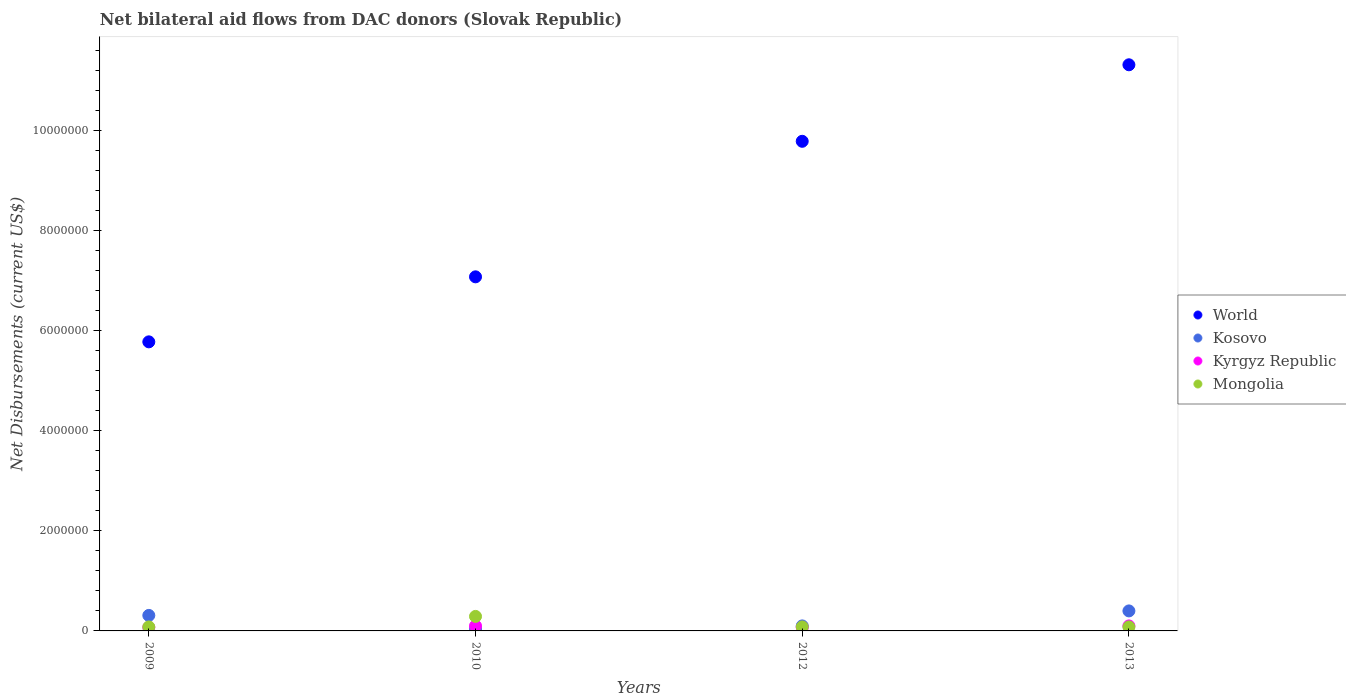How many different coloured dotlines are there?
Provide a succinct answer. 4. What is the net bilateral aid flows in World in 2012?
Your answer should be compact. 9.79e+06. Across all years, what is the maximum net bilateral aid flows in World?
Ensure brevity in your answer.  1.13e+07. Across all years, what is the minimum net bilateral aid flows in Kosovo?
Ensure brevity in your answer.  4.00e+04. In which year was the net bilateral aid flows in Mongolia maximum?
Your answer should be compact. 2010. What is the total net bilateral aid flows in Mongolia in the graph?
Offer a very short reply. 5.30e+05. What is the average net bilateral aid flows in Kyrgyz Republic per year?
Provide a short and direct response. 8.50e+04. In the year 2009, what is the difference between the net bilateral aid flows in Kosovo and net bilateral aid flows in Kyrgyz Republic?
Offer a very short reply. 2.40e+05. What is the ratio of the net bilateral aid flows in Mongolia in 2010 to that in 2012?
Offer a very short reply. 3.62. Is the net bilateral aid flows in World in 2009 less than that in 2010?
Your response must be concise. Yes. Is the difference between the net bilateral aid flows in Kosovo in 2009 and 2010 greater than the difference between the net bilateral aid flows in Kyrgyz Republic in 2009 and 2010?
Give a very brief answer. Yes. What is the difference between the highest and the lowest net bilateral aid flows in World?
Your answer should be very brief. 5.54e+06. In how many years, is the net bilateral aid flows in Kosovo greater than the average net bilateral aid flows in Kosovo taken over all years?
Offer a terse response. 2. Is it the case that in every year, the sum of the net bilateral aid flows in Mongolia and net bilateral aid flows in Kosovo  is greater than the net bilateral aid flows in Kyrgyz Republic?
Offer a very short reply. Yes. Is the net bilateral aid flows in World strictly greater than the net bilateral aid flows in Kyrgyz Republic over the years?
Ensure brevity in your answer.  Yes. Is the net bilateral aid flows in Mongolia strictly less than the net bilateral aid flows in Kyrgyz Republic over the years?
Give a very brief answer. No. How many years are there in the graph?
Give a very brief answer. 4. What is the difference between two consecutive major ticks on the Y-axis?
Your answer should be compact. 2.00e+06. Are the values on the major ticks of Y-axis written in scientific E-notation?
Your answer should be very brief. No. Does the graph contain any zero values?
Provide a short and direct response. No. Does the graph contain grids?
Your response must be concise. No. Where does the legend appear in the graph?
Give a very brief answer. Center right. How many legend labels are there?
Provide a short and direct response. 4. What is the title of the graph?
Keep it short and to the point. Net bilateral aid flows from DAC donors (Slovak Republic). Does "Norway" appear as one of the legend labels in the graph?
Your response must be concise. No. What is the label or title of the X-axis?
Give a very brief answer. Years. What is the label or title of the Y-axis?
Provide a succinct answer. Net Disbursements (current US$). What is the Net Disbursements (current US$) of World in 2009?
Provide a short and direct response. 5.78e+06. What is the Net Disbursements (current US$) of Kosovo in 2009?
Give a very brief answer. 3.10e+05. What is the Net Disbursements (current US$) of World in 2010?
Your response must be concise. 7.08e+06. What is the Net Disbursements (current US$) in World in 2012?
Offer a very short reply. 9.79e+06. What is the Net Disbursements (current US$) of Kyrgyz Republic in 2012?
Your answer should be very brief. 7.00e+04. What is the Net Disbursements (current US$) of World in 2013?
Your answer should be very brief. 1.13e+07. What is the Net Disbursements (current US$) of Kosovo in 2013?
Give a very brief answer. 4.00e+05. Across all years, what is the maximum Net Disbursements (current US$) in World?
Offer a very short reply. 1.13e+07. Across all years, what is the maximum Net Disbursements (current US$) in Mongolia?
Your answer should be very brief. 2.90e+05. Across all years, what is the minimum Net Disbursements (current US$) in World?
Provide a succinct answer. 5.78e+06. Across all years, what is the minimum Net Disbursements (current US$) of Kyrgyz Republic?
Your answer should be very brief. 7.00e+04. What is the total Net Disbursements (current US$) in World in the graph?
Your answer should be compact. 3.40e+07. What is the total Net Disbursements (current US$) of Kosovo in the graph?
Your answer should be very brief. 8.50e+05. What is the total Net Disbursements (current US$) in Kyrgyz Republic in the graph?
Ensure brevity in your answer.  3.40e+05. What is the total Net Disbursements (current US$) in Mongolia in the graph?
Provide a short and direct response. 5.30e+05. What is the difference between the Net Disbursements (current US$) in World in 2009 and that in 2010?
Give a very brief answer. -1.30e+06. What is the difference between the Net Disbursements (current US$) in Kosovo in 2009 and that in 2010?
Your response must be concise. 2.70e+05. What is the difference between the Net Disbursements (current US$) of Kyrgyz Republic in 2009 and that in 2010?
Provide a short and direct response. -3.00e+04. What is the difference between the Net Disbursements (current US$) of Mongolia in 2009 and that in 2010?
Offer a very short reply. -2.10e+05. What is the difference between the Net Disbursements (current US$) of World in 2009 and that in 2012?
Offer a terse response. -4.01e+06. What is the difference between the Net Disbursements (current US$) of Kosovo in 2009 and that in 2012?
Offer a very short reply. 2.10e+05. What is the difference between the Net Disbursements (current US$) of Kyrgyz Republic in 2009 and that in 2012?
Your response must be concise. 0. What is the difference between the Net Disbursements (current US$) of Mongolia in 2009 and that in 2012?
Ensure brevity in your answer.  0. What is the difference between the Net Disbursements (current US$) of World in 2009 and that in 2013?
Provide a succinct answer. -5.54e+06. What is the difference between the Net Disbursements (current US$) of Kyrgyz Republic in 2009 and that in 2013?
Offer a terse response. -3.00e+04. What is the difference between the Net Disbursements (current US$) of Mongolia in 2009 and that in 2013?
Offer a very short reply. 0. What is the difference between the Net Disbursements (current US$) in World in 2010 and that in 2012?
Offer a terse response. -2.71e+06. What is the difference between the Net Disbursements (current US$) in World in 2010 and that in 2013?
Offer a very short reply. -4.24e+06. What is the difference between the Net Disbursements (current US$) of Kosovo in 2010 and that in 2013?
Your answer should be compact. -3.60e+05. What is the difference between the Net Disbursements (current US$) of Kyrgyz Republic in 2010 and that in 2013?
Offer a terse response. 0. What is the difference between the Net Disbursements (current US$) of Mongolia in 2010 and that in 2013?
Make the answer very short. 2.10e+05. What is the difference between the Net Disbursements (current US$) of World in 2012 and that in 2013?
Offer a very short reply. -1.53e+06. What is the difference between the Net Disbursements (current US$) in Mongolia in 2012 and that in 2013?
Make the answer very short. 0. What is the difference between the Net Disbursements (current US$) of World in 2009 and the Net Disbursements (current US$) of Kosovo in 2010?
Give a very brief answer. 5.74e+06. What is the difference between the Net Disbursements (current US$) of World in 2009 and the Net Disbursements (current US$) of Kyrgyz Republic in 2010?
Offer a terse response. 5.68e+06. What is the difference between the Net Disbursements (current US$) of World in 2009 and the Net Disbursements (current US$) of Mongolia in 2010?
Make the answer very short. 5.49e+06. What is the difference between the Net Disbursements (current US$) in Kosovo in 2009 and the Net Disbursements (current US$) in Kyrgyz Republic in 2010?
Offer a terse response. 2.10e+05. What is the difference between the Net Disbursements (current US$) of Kyrgyz Republic in 2009 and the Net Disbursements (current US$) of Mongolia in 2010?
Offer a very short reply. -2.20e+05. What is the difference between the Net Disbursements (current US$) of World in 2009 and the Net Disbursements (current US$) of Kosovo in 2012?
Your response must be concise. 5.68e+06. What is the difference between the Net Disbursements (current US$) in World in 2009 and the Net Disbursements (current US$) in Kyrgyz Republic in 2012?
Offer a terse response. 5.71e+06. What is the difference between the Net Disbursements (current US$) of World in 2009 and the Net Disbursements (current US$) of Mongolia in 2012?
Your answer should be very brief. 5.70e+06. What is the difference between the Net Disbursements (current US$) in Kosovo in 2009 and the Net Disbursements (current US$) in Kyrgyz Republic in 2012?
Your answer should be compact. 2.40e+05. What is the difference between the Net Disbursements (current US$) of World in 2009 and the Net Disbursements (current US$) of Kosovo in 2013?
Provide a short and direct response. 5.38e+06. What is the difference between the Net Disbursements (current US$) of World in 2009 and the Net Disbursements (current US$) of Kyrgyz Republic in 2013?
Offer a very short reply. 5.68e+06. What is the difference between the Net Disbursements (current US$) in World in 2009 and the Net Disbursements (current US$) in Mongolia in 2013?
Offer a terse response. 5.70e+06. What is the difference between the Net Disbursements (current US$) in Kosovo in 2009 and the Net Disbursements (current US$) in Mongolia in 2013?
Provide a short and direct response. 2.30e+05. What is the difference between the Net Disbursements (current US$) of World in 2010 and the Net Disbursements (current US$) of Kosovo in 2012?
Your response must be concise. 6.98e+06. What is the difference between the Net Disbursements (current US$) of World in 2010 and the Net Disbursements (current US$) of Kyrgyz Republic in 2012?
Your answer should be very brief. 7.01e+06. What is the difference between the Net Disbursements (current US$) of World in 2010 and the Net Disbursements (current US$) of Mongolia in 2012?
Offer a very short reply. 7.00e+06. What is the difference between the Net Disbursements (current US$) of World in 2010 and the Net Disbursements (current US$) of Kosovo in 2013?
Make the answer very short. 6.68e+06. What is the difference between the Net Disbursements (current US$) in World in 2010 and the Net Disbursements (current US$) in Kyrgyz Republic in 2013?
Your answer should be very brief. 6.98e+06. What is the difference between the Net Disbursements (current US$) in Kyrgyz Republic in 2010 and the Net Disbursements (current US$) in Mongolia in 2013?
Your answer should be compact. 2.00e+04. What is the difference between the Net Disbursements (current US$) of World in 2012 and the Net Disbursements (current US$) of Kosovo in 2013?
Provide a short and direct response. 9.39e+06. What is the difference between the Net Disbursements (current US$) of World in 2012 and the Net Disbursements (current US$) of Kyrgyz Republic in 2013?
Your answer should be compact. 9.69e+06. What is the difference between the Net Disbursements (current US$) in World in 2012 and the Net Disbursements (current US$) in Mongolia in 2013?
Make the answer very short. 9.71e+06. What is the difference between the Net Disbursements (current US$) in Kosovo in 2012 and the Net Disbursements (current US$) in Mongolia in 2013?
Give a very brief answer. 2.00e+04. What is the difference between the Net Disbursements (current US$) in Kyrgyz Republic in 2012 and the Net Disbursements (current US$) in Mongolia in 2013?
Provide a succinct answer. -10000. What is the average Net Disbursements (current US$) in World per year?
Offer a very short reply. 8.49e+06. What is the average Net Disbursements (current US$) in Kosovo per year?
Keep it short and to the point. 2.12e+05. What is the average Net Disbursements (current US$) in Kyrgyz Republic per year?
Ensure brevity in your answer.  8.50e+04. What is the average Net Disbursements (current US$) of Mongolia per year?
Offer a very short reply. 1.32e+05. In the year 2009, what is the difference between the Net Disbursements (current US$) in World and Net Disbursements (current US$) in Kosovo?
Offer a very short reply. 5.47e+06. In the year 2009, what is the difference between the Net Disbursements (current US$) in World and Net Disbursements (current US$) in Kyrgyz Republic?
Provide a short and direct response. 5.71e+06. In the year 2009, what is the difference between the Net Disbursements (current US$) of World and Net Disbursements (current US$) of Mongolia?
Provide a succinct answer. 5.70e+06. In the year 2009, what is the difference between the Net Disbursements (current US$) in Kosovo and Net Disbursements (current US$) in Kyrgyz Republic?
Keep it short and to the point. 2.40e+05. In the year 2009, what is the difference between the Net Disbursements (current US$) of Kyrgyz Republic and Net Disbursements (current US$) of Mongolia?
Your answer should be compact. -10000. In the year 2010, what is the difference between the Net Disbursements (current US$) in World and Net Disbursements (current US$) in Kosovo?
Keep it short and to the point. 7.04e+06. In the year 2010, what is the difference between the Net Disbursements (current US$) of World and Net Disbursements (current US$) of Kyrgyz Republic?
Your answer should be very brief. 6.98e+06. In the year 2010, what is the difference between the Net Disbursements (current US$) in World and Net Disbursements (current US$) in Mongolia?
Offer a very short reply. 6.79e+06. In the year 2010, what is the difference between the Net Disbursements (current US$) of Kosovo and Net Disbursements (current US$) of Kyrgyz Republic?
Offer a very short reply. -6.00e+04. In the year 2010, what is the difference between the Net Disbursements (current US$) of Kosovo and Net Disbursements (current US$) of Mongolia?
Your response must be concise. -2.50e+05. In the year 2010, what is the difference between the Net Disbursements (current US$) in Kyrgyz Republic and Net Disbursements (current US$) in Mongolia?
Give a very brief answer. -1.90e+05. In the year 2012, what is the difference between the Net Disbursements (current US$) in World and Net Disbursements (current US$) in Kosovo?
Offer a very short reply. 9.69e+06. In the year 2012, what is the difference between the Net Disbursements (current US$) of World and Net Disbursements (current US$) of Kyrgyz Republic?
Your answer should be compact. 9.72e+06. In the year 2012, what is the difference between the Net Disbursements (current US$) of World and Net Disbursements (current US$) of Mongolia?
Your answer should be compact. 9.71e+06. In the year 2012, what is the difference between the Net Disbursements (current US$) in Kosovo and Net Disbursements (current US$) in Kyrgyz Republic?
Provide a succinct answer. 3.00e+04. In the year 2013, what is the difference between the Net Disbursements (current US$) in World and Net Disbursements (current US$) in Kosovo?
Give a very brief answer. 1.09e+07. In the year 2013, what is the difference between the Net Disbursements (current US$) in World and Net Disbursements (current US$) in Kyrgyz Republic?
Offer a very short reply. 1.12e+07. In the year 2013, what is the difference between the Net Disbursements (current US$) in World and Net Disbursements (current US$) in Mongolia?
Provide a short and direct response. 1.12e+07. In the year 2013, what is the difference between the Net Disbursements (current US$) of Kosovo and Net Disbursements (current US$) of Kyrgyz Republic?
Keep it short and to the point. 3.00e+05. In the year 2013, what is the difference between the Net Disbursements (current US$) of Kyrgyz Republic and Net Disbursements (current US$) of Mongolia?
Make the answer very short. 2.00e+04. What is the ratio of the Net Disbursements (current US$) in World in 2009 to that in 2010?
Ensure brevity in your answer.  0.82. What is the ratio of the Net Disbursements (current US$) of Kosovo in 2009 to that in 2010?
Your answer should be very brief. 7.75. What is the ratio of the Net Disbursements (current US$) in Mongolia in 2009 to that in 2010?
Ensure brevity in your answer.  0.28. What is the ratio of the Net Disbursements (current US$) of World in 2009 to that in 2012?
Give a very brief answer. 0.59. What is the ratio of the Net Disbursements (current US$) in Kosovo in 2009 to that in 2012?
Your response must be concise. 3.1. What is the ratio of the Net Disbursements (current US$) in Mongolia in 2009 to that in 2012?
Your answer should be very brief. 1. What is the ratio of the Net Disbursements (current US$) of World in 2009 to that in 2013?
Provide a succinct answer. 0.51. What is the ratio of the Net Disbursements (current US$) in Kosovo in 2009 to that in 2013?
Your answer should be very brief. 0.78. What is the ratio of the Net Disbursements (current US$) of Kyrgyz Republic in 2009 to that in 2013?
Keep it short and to the point. 0.7. What is the ratio of the Net Disbursements (current US$) of Mongolia in 2009 to that in 2013?
Offer a terse response. 1. What is the ratio of the Net Disbursements (current US$) in World in 2010 to that in 2012?
Your response must be concise. 0.72. What is the ratio of the Net Disbursements (current US$) of Kyrgyz Republic in 2010 to that in 2012?
Make the answer very short. 1.43. What is the ratio of the Net Disbursements (current US$) in Mongolia in 2010 to that in 2012?
Offer a terse response. 3.62. What is the ratio of the Net Disbursements (current US$) of World in 2010 to that in 2013?
Make the answer very short. 0.63. What is the ratio of the Net Disbursements (current US$) of Kosovo in 2010 to that in 2013?
Keep it short and to the point. 0.1. What is the ratio of the Net Disbursements (current US$) of Mongolia in 2010 to that in 2013?
Keep it short and to the point. 3.62. What is the ratio of the Net Disbursements (current US$) of World in 2012 to that in 2013?
Make the answer very short. 0.86. What is the ratio of the Net Disbursements (current US$) of Kosovo in 2012 to that in 2013?
Offer a terse response. 0.25. What is the ratio of the Net Disbursements (current US$) of Kyrgyz Republic in 2012 to that in 2013?
Your answer should be compact. 0.7. What is the difference between the highest and the second highest Net Disbursements (current US$) of World?
Ensure brevity in your answer.  1.53e+06. What is the difference between the highest and the second highest Net Disbursements (current US$) of Kosovo?
Your answer should be compact. 9.00e+04. What is the difference between the highest and the second highest Net Disbursements (current US$) of Kyrgyz Republic?
Your answer should be compact. 0. What is the difference between the highest and the lowest Net Disbursements (current US$) of World?
Ensure brevity in your answer.  5.54e+06. What is the difference between the highest and the lowest Net Disbursements (current US$) in Kosovo?
Make the answer very short. 3.60e+05. What is the difference between the highest and the lowest Net Disbursements (current US$) of Kyrgyz Republic?
Offer a terse response. 3.00e+04. What is the difference between the highest and the lowest Net Disbursements (current US$) in Mongolia?
Make the answer very short. 2.10e+05. 